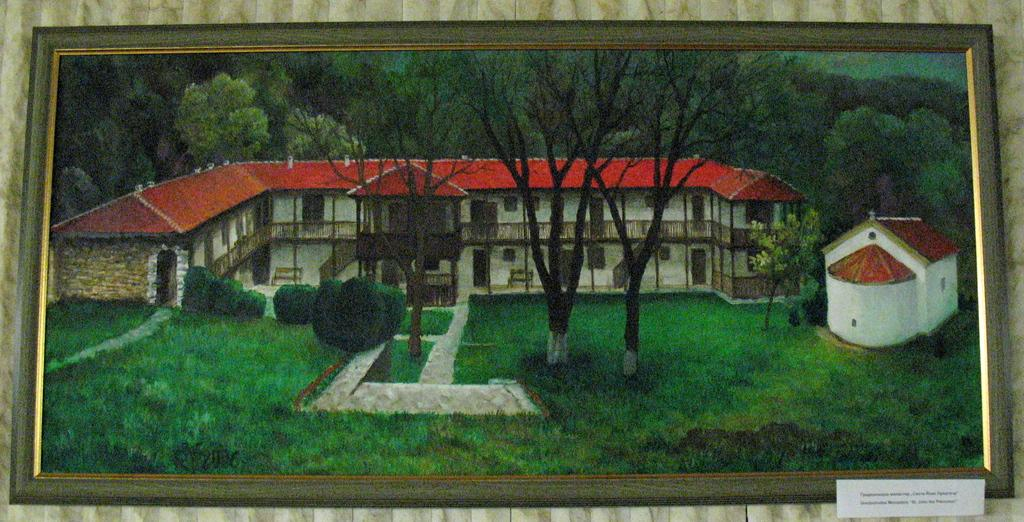Where is the image located in the scene? The image is on a wall. What is placed in front of the image? There is an information card in front of the image. What types of vegetation are present in the image? The image contains trees and plants. What animals are depicted in the image? The image contains horses. What type of ground is visible in the image? The image contains grass. What type of stove can be seen in the image? There is no stove present in the image. How does the knee of the horse in the image bend? There is no horse with a knee in the image; it contains horses but does not show any specific body parts. 